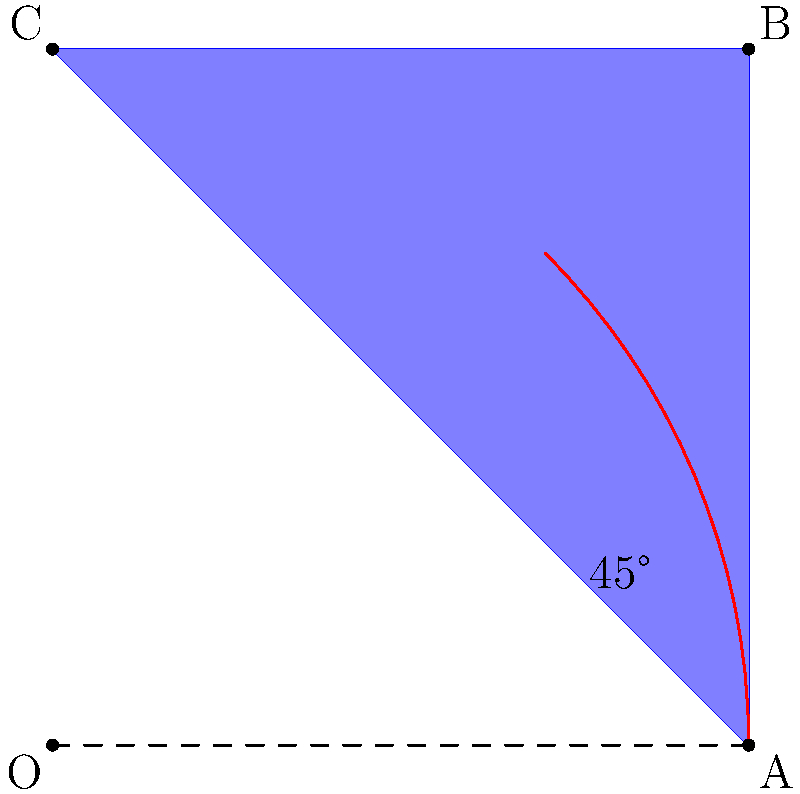You're designing a new smoothie cup for your organic grape smoothies. The cup has a square base with side length 2 units and is centered at the origin. If you rotate the cup 45° counterclockwise around the origin, what will be the new coordinates of point B (originally at (2,2))? To solve this problem, we'll use the rotation formula for a point (x,y) rotated θ degrees counterclockwise around the origin:

x' = x cos θ - y sin θ
y' = x sin θ + y cos θ

Steps:
1. Identify the initial coordinates of point B: (2,2)
2. The rotation angle is 45°
3. Calculate cos 45° and sin 45°:
   cos 45° = sin 45° = $\frac{1}{\sqrt{2}} ≈ 0.7071$
4. Apply the rotation formula:
   x' = 2 cos 45° - 2 sin 45° = 2($\frac{1}{\sqrt{2}}) - 2($\frac{1}{\sqrt{2}}) = 0
   y' = 2 sin 45° + 2 cos 45° = 2($\frac{1}{\sqrt{2}}) + 2($\frac{1}{\sqrt{2}}) = 2$\sqrt{2}$ ≈ 2.8284
5. The new coordinates of point B are (0, 2$\sqrt{2}$)
Answer: (0, 2$\sqrt{2}$) 